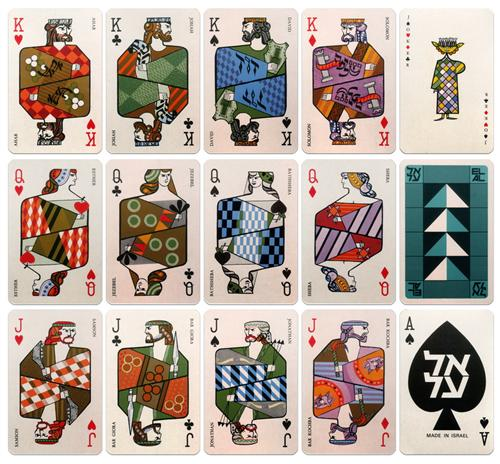Explain the visual content of the image in great detail. The image presents a vibrant collection of playing cards, each adorned with geometric patterns and bold colors that are reminiscent of mid-century modern art. The cards are arranged in a grid layout, with each row dedicated to a specific face card - kings, queens, and jacks. 

Each card is a unique piece of art, with its own distinct design and color scheme. The kings, queens, and jacks are illustrated with a variety of shapes and patterns, creating a dynamic visual effect. The cards are outlined by a thin black line, providing a stark contrast against the white background.

The art style of the cards is characterized by its simplicity, clean lines, and bold colors, which are hallmarks of the mid-century modern art genre. Despite the simplicity of the designs, there's a certain complexity in the way the geometric shapes and colors interact, creating a sense of depth and dimension.

Overall, the image is a celebration of mid-century modern art, expressed through the familiar medium of playing cards. It's a fusion of traditional and modern elements, resulting in a unique and captivating piece of art. 